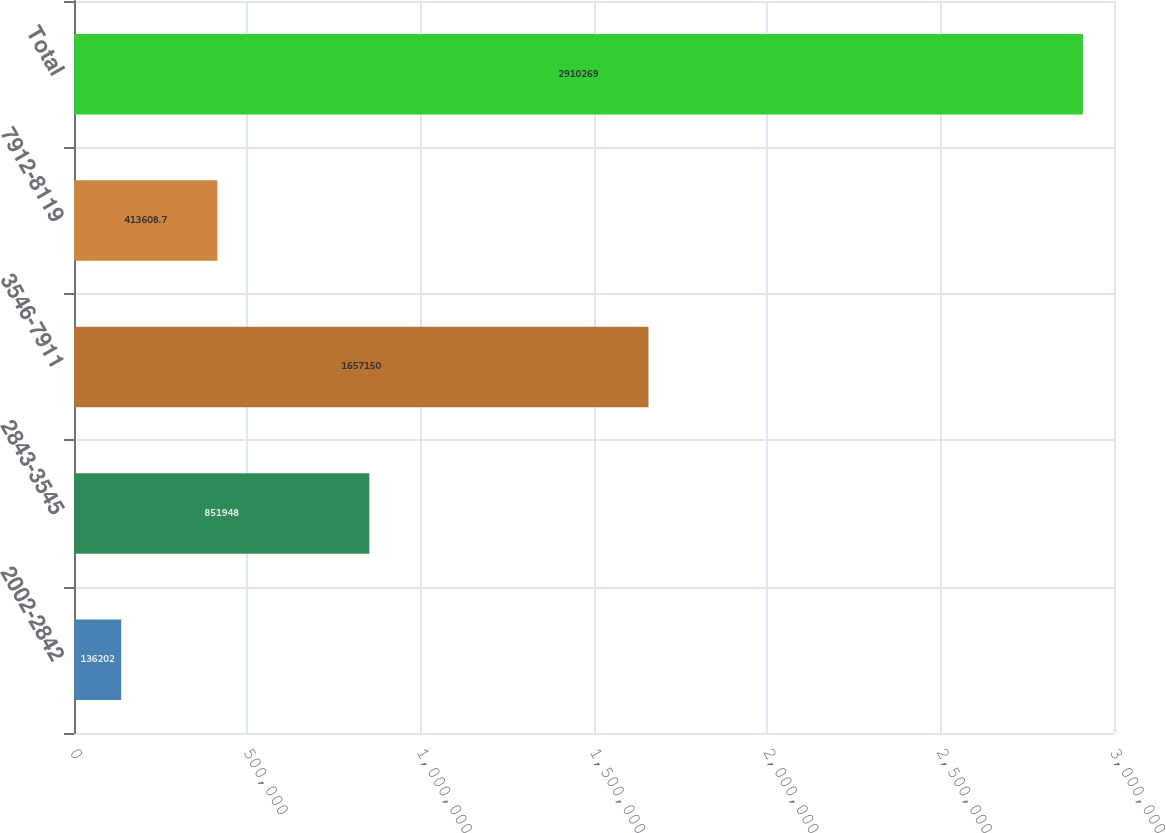Convert chart to OTSL. <chart><loc_0><loc_0><loc_500><loc_500><bar_chart><fcel>2002-2842<fcel>2843-3545<fcel>3546-7911<fcel>7912-8119<fcel>Total<nl><fcel>136202<fcel>851948<fcel>1.65715e+06<fcel>413609<fcel>2.91027e+06<nl></chart> 